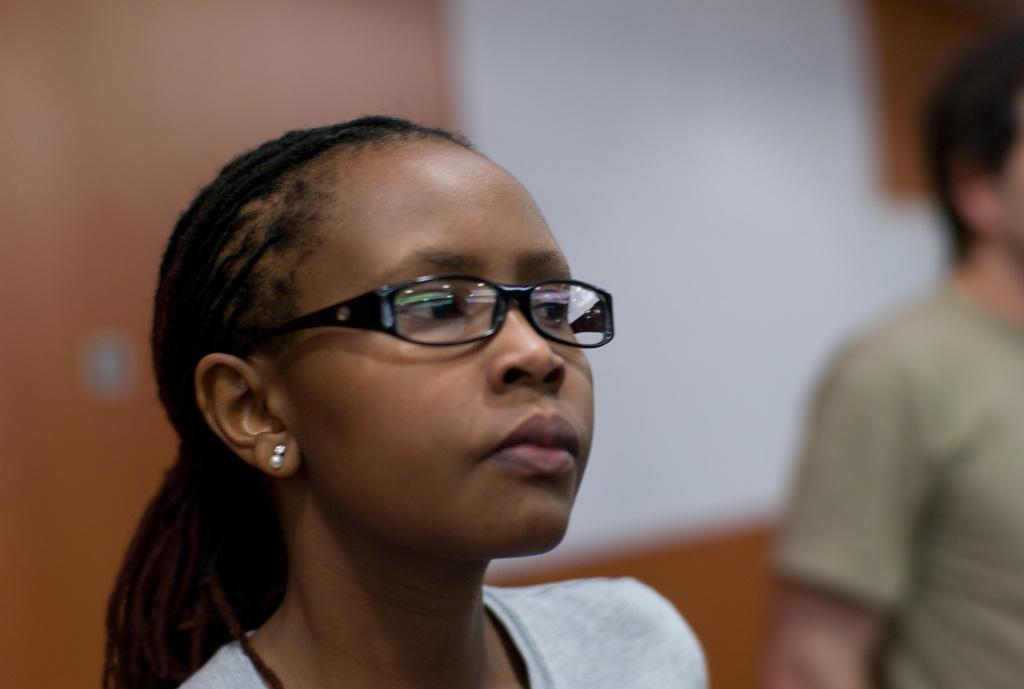How many people are present in the image? There are two people in the image. Can you describe the background of the image? The background of the image is blurred. What type of food is the father cooking on the stove in the image? There is no father or stove present in the image, and therefore no such cooking activity can be observed. 